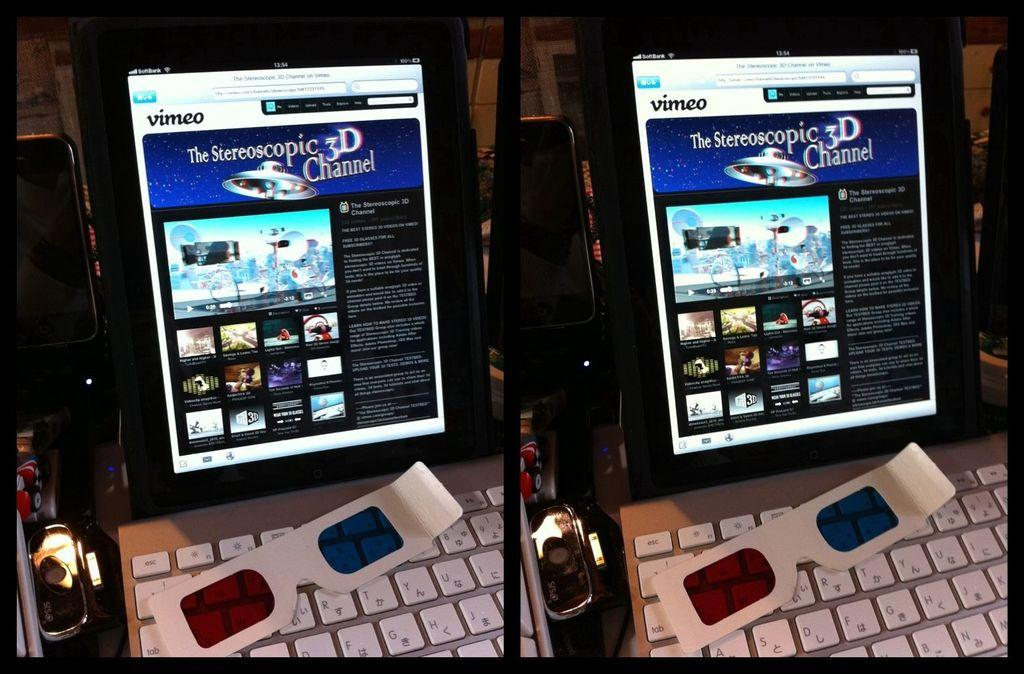<image>
Give a short and clear explanation of the subsequent image. A computer monitor shows Vimeo in the left corner. 